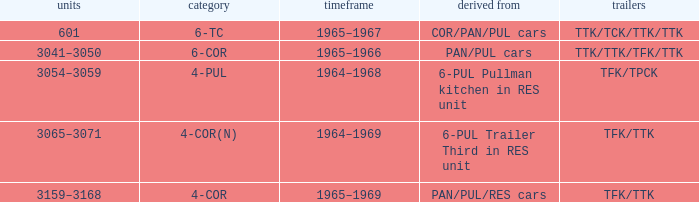Would you mind parsing the complete table? {'header': ['units', 'category', 'timeframe', 'derived from', 'trailers'], 'rows': [['601', '6-TC', '1965–1967', 'COR/PAN/PUL cars', 'TTK/TCK/TTK/TTK'], ['3041–3050', '6-COR', '1965–1966', 'PAN/PUL cars', 'TTK/TTK/TFK/TTK'], ['3054–3059', '4-PUL', '1964–1968', '6-PUL Pullman kitchen in RES unit', 'TFK/TPCK'], ['3065–3071', '4-COR(N)', '1964–1969', '6-PUL Trailer Third in RES unit', 'TFK/TTK'], ['3159–3168', '4-COR', '1965–1969', 'PAN/PUL/RES cars', 'TFK/TTK']]} Name the typed for formed from 6-pul trailer third in res unit 4-COR(N). 